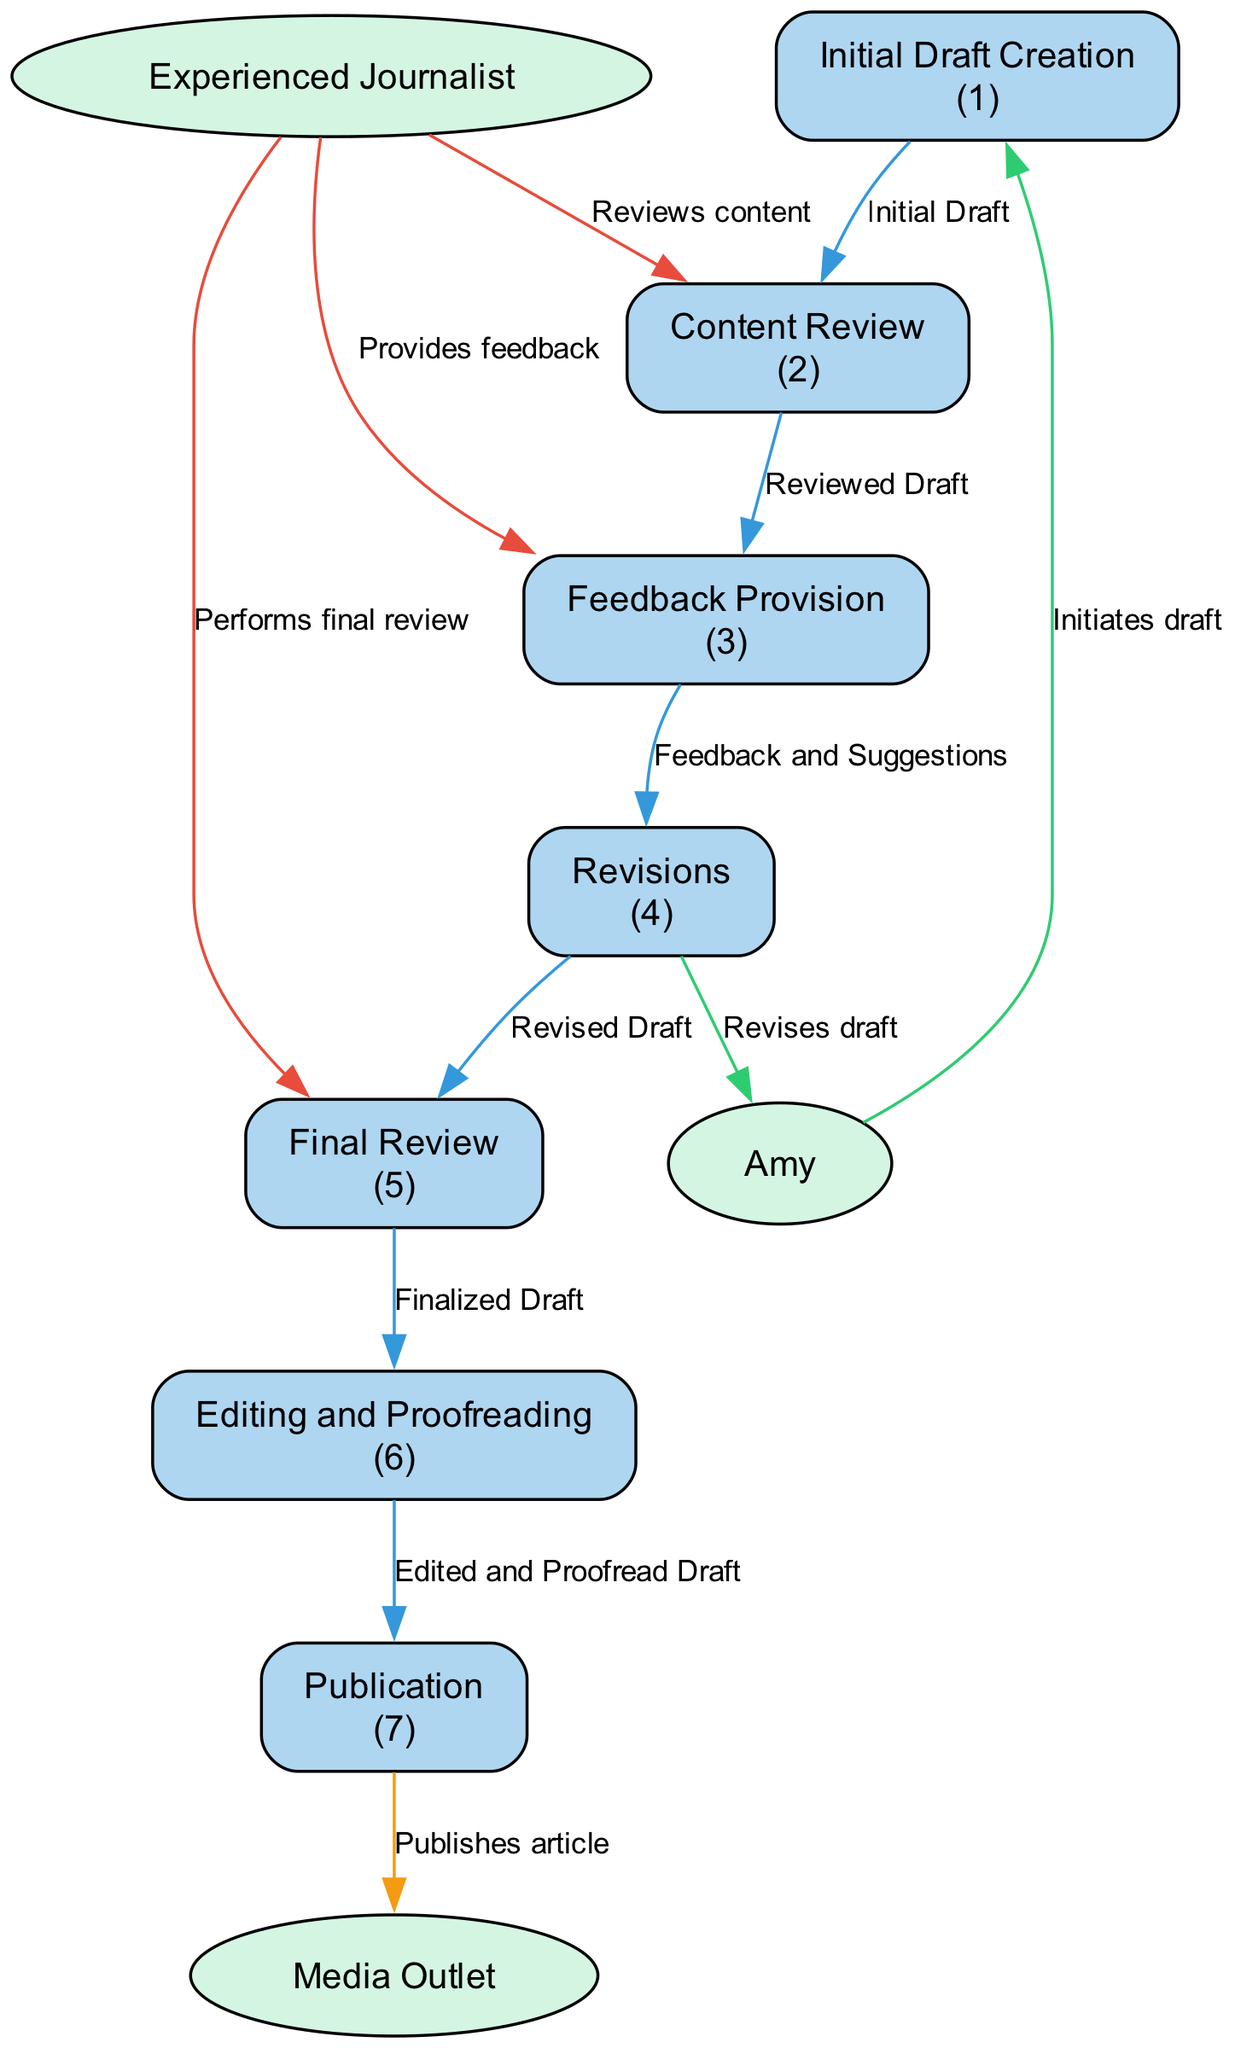What is the first process in the diagram? The diagram indicates that "Initial Draft Creation" is labeled as the first process. This is the first step in the flow from Amy's draft to publication.
Answer: Initial Draft Creation How many external entities are present in the diagram? There are three external entities depicted in the diagram: Amy, the Experienced Journalist, and the Media Outlet. By counting these, we find the total number of external entities.
Answer: 3 What does the Experienced Journalist do in the diagram? The Experienced Journalist reviews content, provides feedback, and performs a final review, which is illustrated by the different connections from this entity to the processes.
Answer: Reviews content, provides feedback, performs final review What is the last process before publication? The last process before publication is "Editing and Proofreading," which is the step that occurs just before the article is published in the Media Outlet.
Answer: Editing and Proofreading Which process comes after Feedback Provision? The process that follows Feedback Provision according to the diagram is "Revisions," where Amy revises her draft based on the feedback received.
Answer: Revisions Describe the flow of data from the Initial Draft Creation to Publication. Data flows from "Initial Draft Creation" (creating the initial draft) to "Content Review" (where the draft is reviewed), then to "Feedback Provision" (where feedback is given), followed by "Revisions" (where Amy revises), "Final Review" (where the final review is conducted), and finally to "Editing and Proofreading," which leads to the publication step.
Answer: From Initial Draft Creation to Publication: Initial Draft → Content Review → Feedback Provision → Revisions → Final Review → Editing and Proofreading → Publication How does Amy utilize feedback according to the diagram? Amy receives feedback and suggestions from the Experienced Journalist through the data flow from "Feedback Provision" to "Revisions." This indicates that she uses the feedback to improve her draft.
Answer: She revises the draft based on feedback What type of diagram is represented here? The diagram represents a Data Flow Diagram, which visually illustrates the processes, data flows, and external entities involved in the content review and feedback loop for Amy's writing.
Answer: Data Flow Diagram Which process includes the activity of providing feedback? The process that involves providing feedback is "Feedback Provision," which is specifically designated for this purpose in the diagram.
Answer: Feedback Provision 